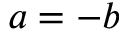Convert formula to latex. <formula><loc_0><loc_0><loc_500><loc_500>a = - b</formula> 